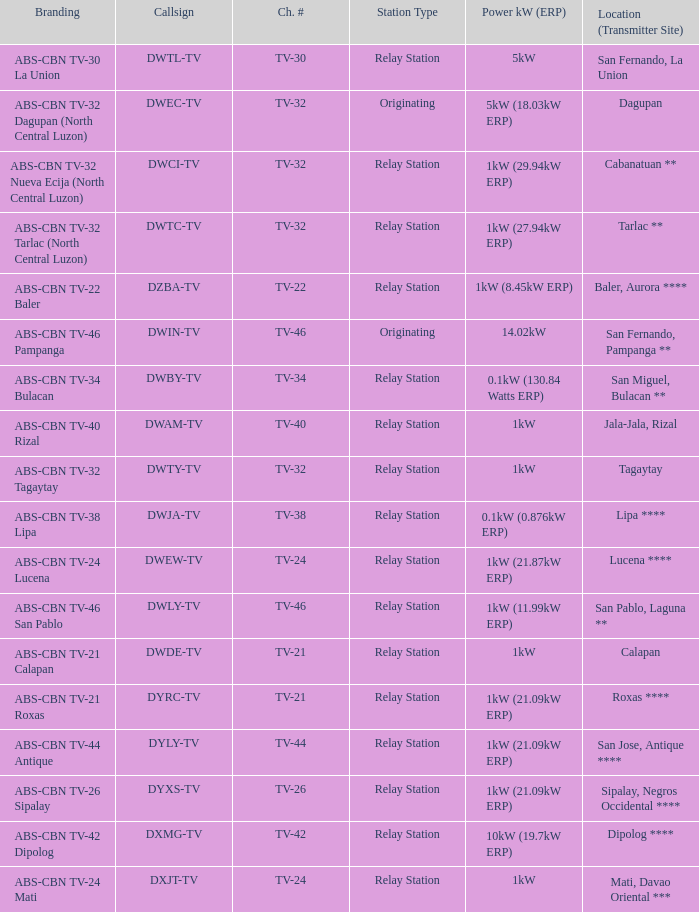What is the brand name associated with the callsign dwci-tv? ABS-CBN TV-32 Nueva Ecija (North Central Luzon). 